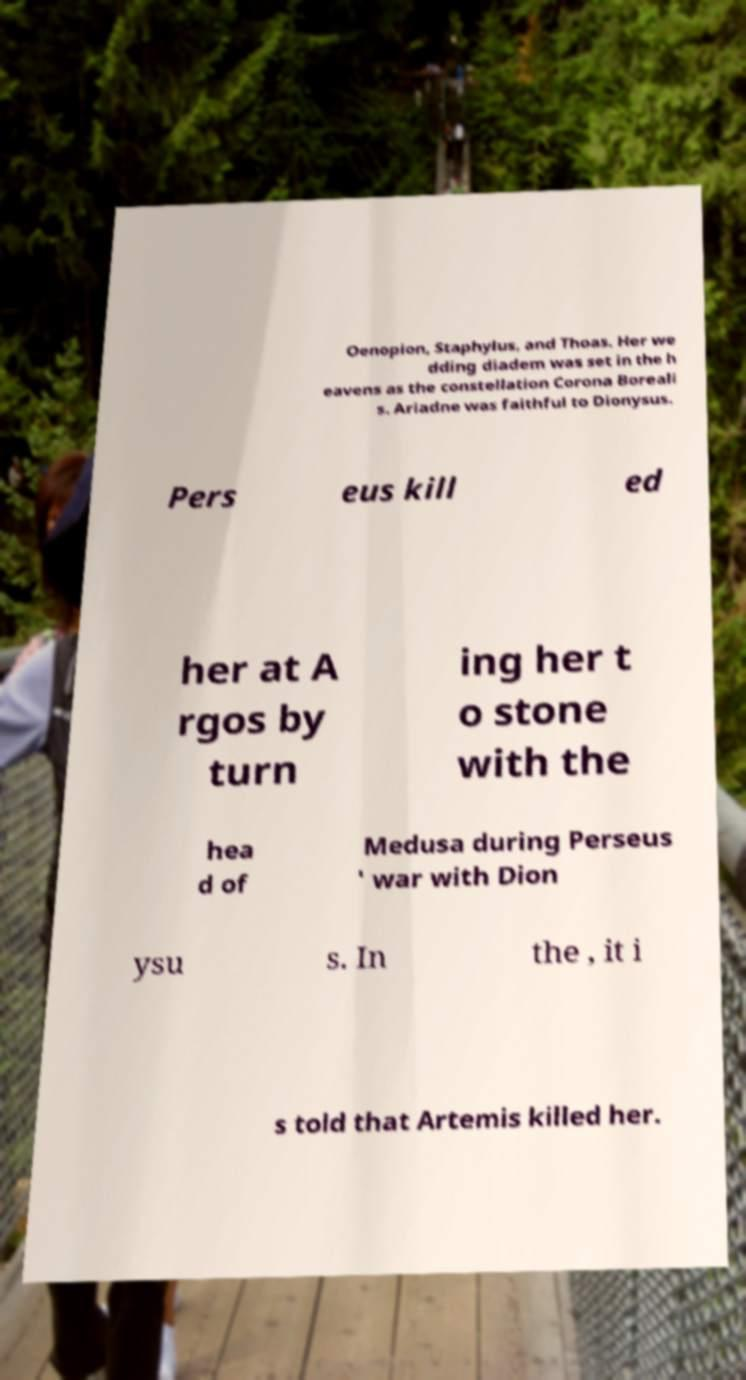Please identify and transcribe the text found in this image. Oenopion, Staphylus, and Thoas. Her we dding diadem was set in the h eavens as the constellation Corona Boreali s. Ariadne was faithful to Dionysus. Pers eus kill ed her at A rgos by turn ing her t o stone with the hea d of Medusa during Perseus ' war with Dion ysu s. In the , it i s told that Artemis killed her. 